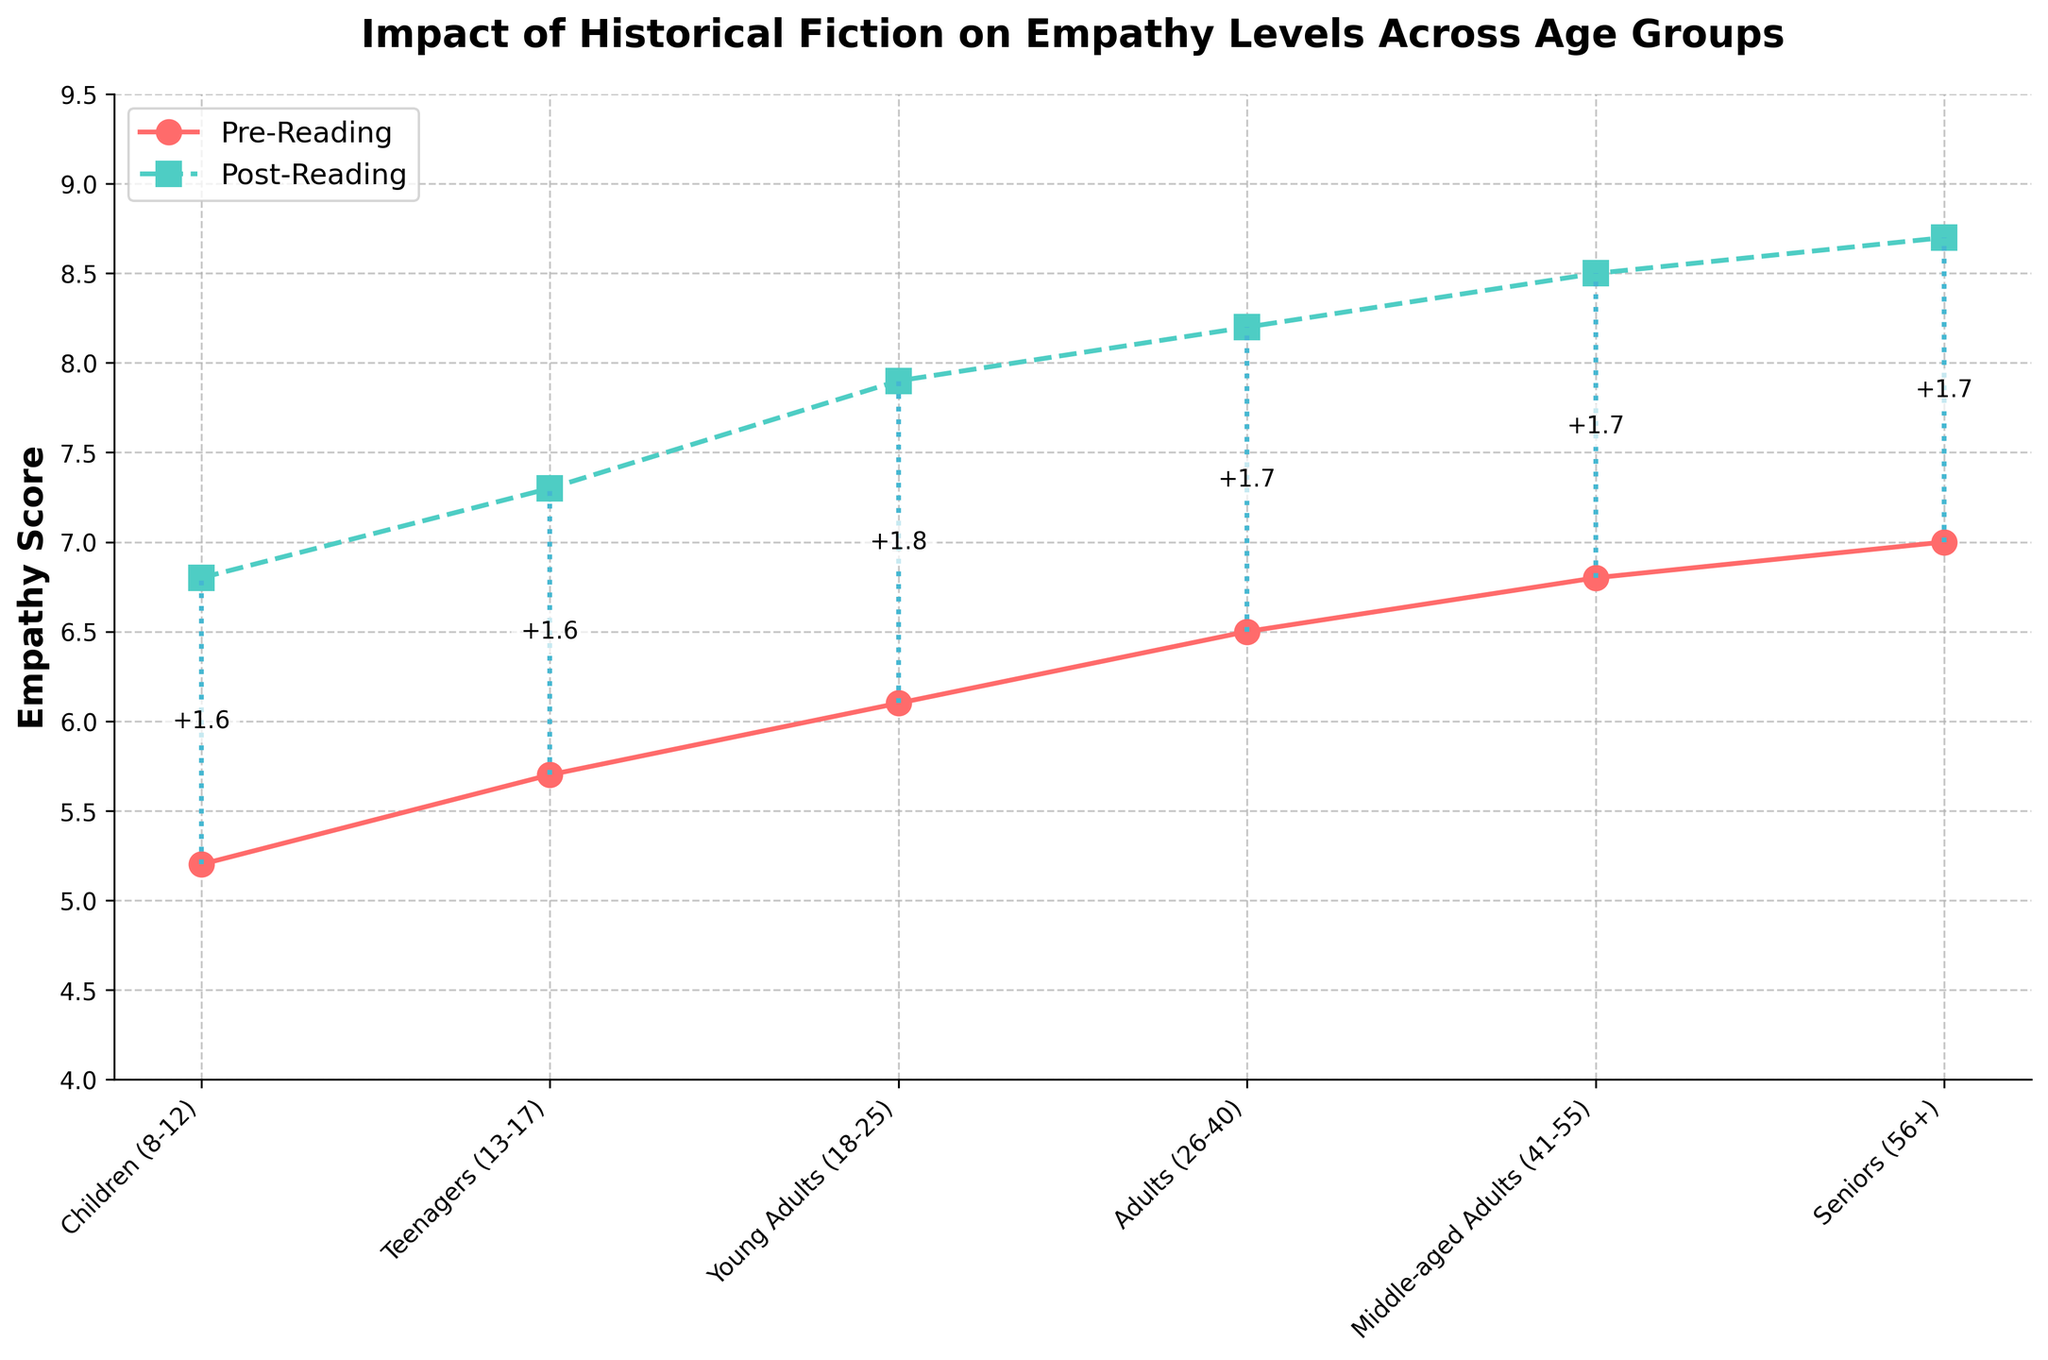What is the average increase in empathy scores across all age groups after reading historical fiction? To find the average increase, calculate the difference between the post-reading and pre-reading empathy scores for each age group, then sum those differences and divide by the number of age groups. The increases are 1.6, 1.6, 1.8, 1.7, 1.7, and 1.7. Adding these gives 10.1. Dividing by 6 age groups gives 1.68
Answer: 1.68 Which age group showed the smallest increase in their empathy score after reading historical fiction? Look at the plotted lines for Pre-Reading and Post-Reading empathy scores for each age group. Determine the differences and see which one is the smallest. The smallest increase is for the Children (8-12) age group with an increase of +1.6
Answer: Children (8-12) By how much did the empathy score increase for the Young Adults (18-25) age group after reading historical fiction? Look at the point on the Post-Reading Empathy Score line corresponding to the Young Adults (18-25) age group, and the point on the Pre-Reading Empathy Score line for the same group. The post-reading score is 7.9, and the pre-reading score is 6.1. The difference is 7.9 - 6.1 = 1.8
Answer: 1.8 Compare the empathy scores of Adults (26-40) before and after reading historical fiction. Which score is higher and by how much? The empathy score for Adults (26-40) before reading is 6.5, and after reading is 8.2. The post-reading score is higher than the pre-reading score. The difference is 8.2 - 6.5 = 1.7
Answer: 1.7 Which two age groups had the highest pre-reading empathy scores, and what were those scores? Examine the Pre-Reading Empathy Score line and look for the highest points. The highest pre-reading empathy scores are for Seniors (56+) with a score of 7.0, and Middle-aged Adults (41-55) with a score of 6.8
Answer: Seniors (56+), Middle-aged Adults (41-55) Is there any age group with a post-reading empathy score higher than 8.0? If yes, which ones and what are their scores? Look at the Post-Reading Empathy Score line and identify points higher than 8.0. The age groups with post-reading scores higher than 8.0 are Young Adults (18-25) with 7.9 just below 8.0 threshold, Adults (26-40) with 8.2, Middle-aged Adults (41-55) with 8.5, and Seniors (56+) with 8.7
Answer: Adults (26-40): 8.2, Middle-aged Adults (41-55): 8.5, Seniors (56+): 8.7 Sum the empathy scores for Teenagers (13-17) and Seniors (56+) after reading historical fiction. What is the total? The post-reading empathy score for Teenagers (13-17) is 7.3, and for Seniors (56+) is 8.7. The total is 7.3 + 8.7 = 16.0
Answer: 16.0 Which age group had the highest post-reading empathy score? Look at the highest point on the Post-Reading Empathy Score line. The highest point corresponds to the Seniors (56+) with a score of 8.7
Answer: Seniors (56+) By how much did the empathy score for Middle-aged Adults (41-55) increase compared to the score for Children (8-12)? Calculate the empathy score increase for both age groups. Middle-aged Adults (41-55) increased from 6.8 to 8.5, an increase of 1.7. Children (8-12) increased from 5.2 to 6.8, an increase of 1.6. The difference in the increase is 1.7 - 1.6 = 0.1
Answer: 0.1 